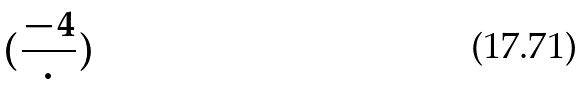<formula> <loc_0><loc_0><loc_500><loc_500>( \frac { - 4 } { \cdot } )</formula> 